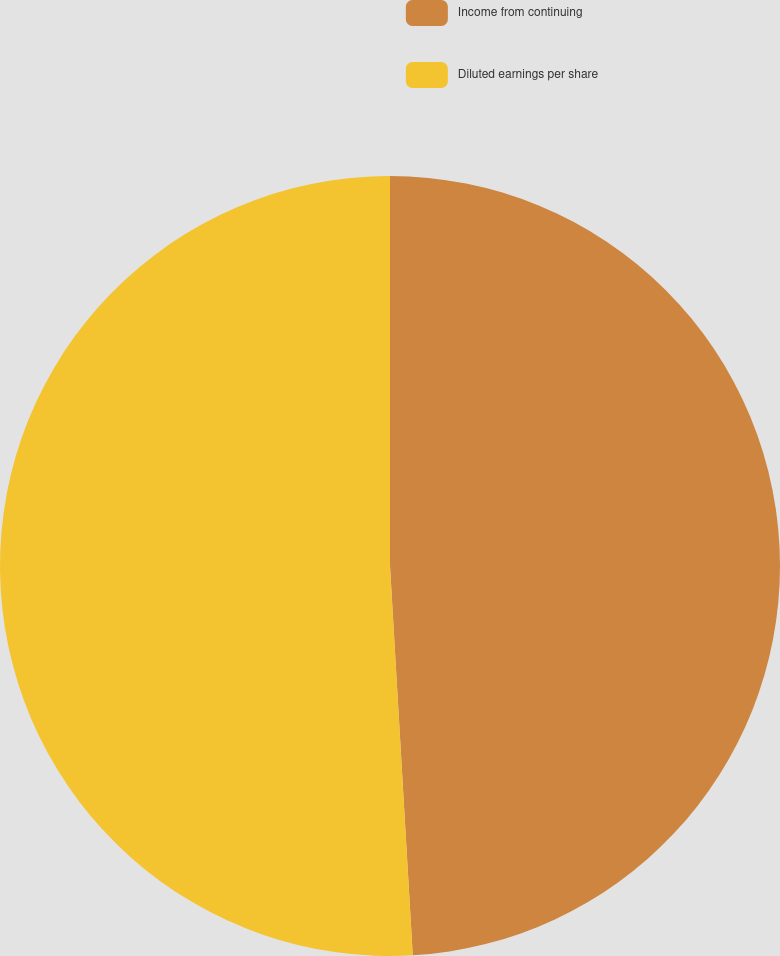Convert chart to OTSL. <chart><loc_0><loc_0><loc_500><loc_500><pie_chart><fcel>Income from continuing<fcel>Diluted earnings per share<nl><fcel>49.07%<fcel>50.93%<nl></chart> 